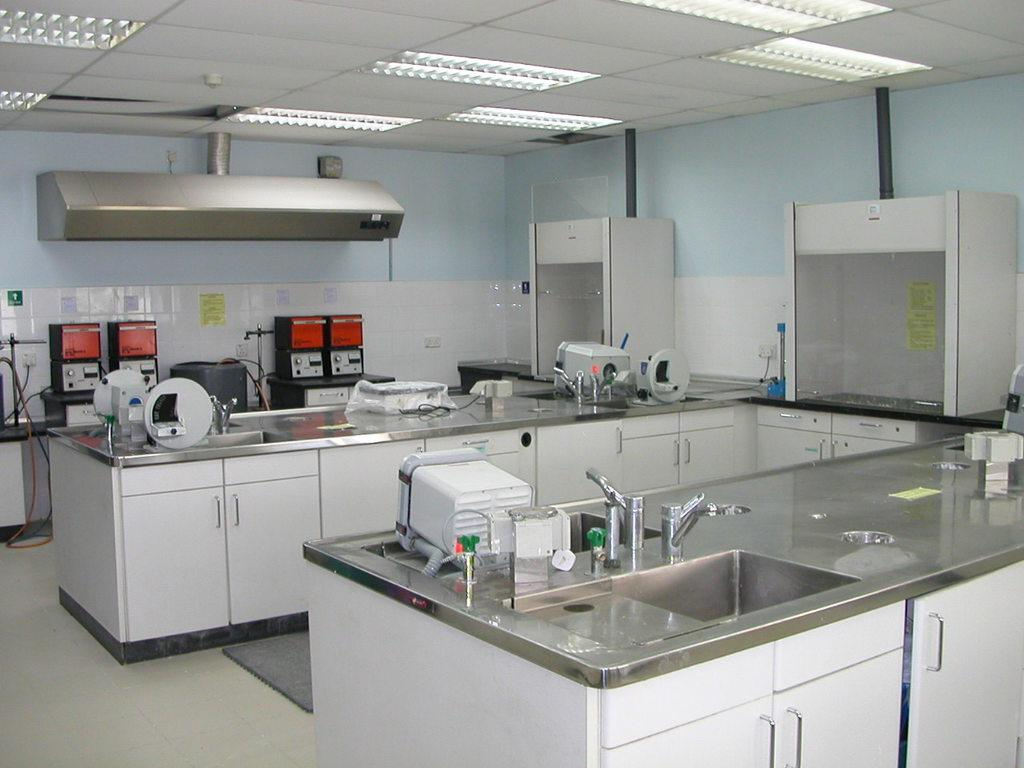What type of furniture is present in the image? There are cupboards in the image. What architectural features can be seen in the image? There are platforms in the image. What type of lighting is present in the image? There are lights in the image. What type of flooring is present in the image? There is a carpet in the image. What type of equipment is present in the image? There are machines in the image. What type of plumbing fixtures are present in the image? There are sinks and taps in the image. What type of objects are present in the image? There are objects in the image. What type of decorations are present on the walls in the image? Posters are on the walls in the image. How does the cannon fire in the image? There is no cannon present in the image. What sense is being stimulated by the objects in the image? The provided facts do not mention any sensory stimulation, so it is not possible to determine which sense is being stimulated by the objects in the image. 